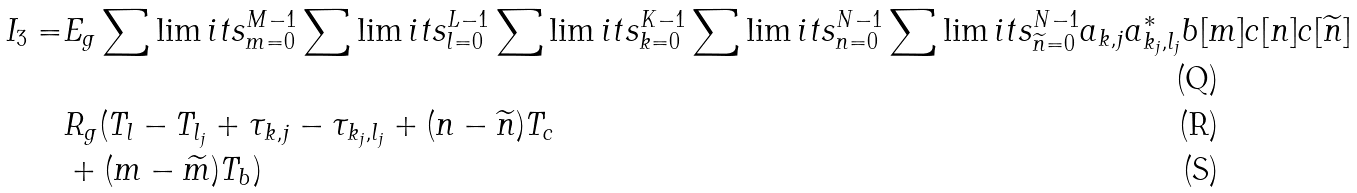<formula> <loc_0><loc_0><loc_500><loc_500>I _ { 3 } = & E _ { g } \sum \lim i t s _ { m = 0 } ^ { M - 1 } \sum \lim i t s _ { l = 0 } ^ { L - 1 } \sum \lim i t s _ { k = 0 } ^ { K - 1 } \sum \lim i t s _ { n = 0 } ^ { N - 1 } \sum \lim i t s _ { \widetilde { n } = 0 } ^ { N - 1 } a _ { k , j } a _ { k _ { j } , l _ { j } } ^ { * } b [ m ] c [ n ] c [ \widetilde { n } ] \\ & R _ { g } ( T _ { l } - T _ { l _ { j } } + \tau _ { k , j } - \tau _ { k _ { j } , l _ { j } } + ( n - \widetilde { n } ) T _ { c } \\ & + ( m - \widetilde { m } ) T _ { b } )</formula> 